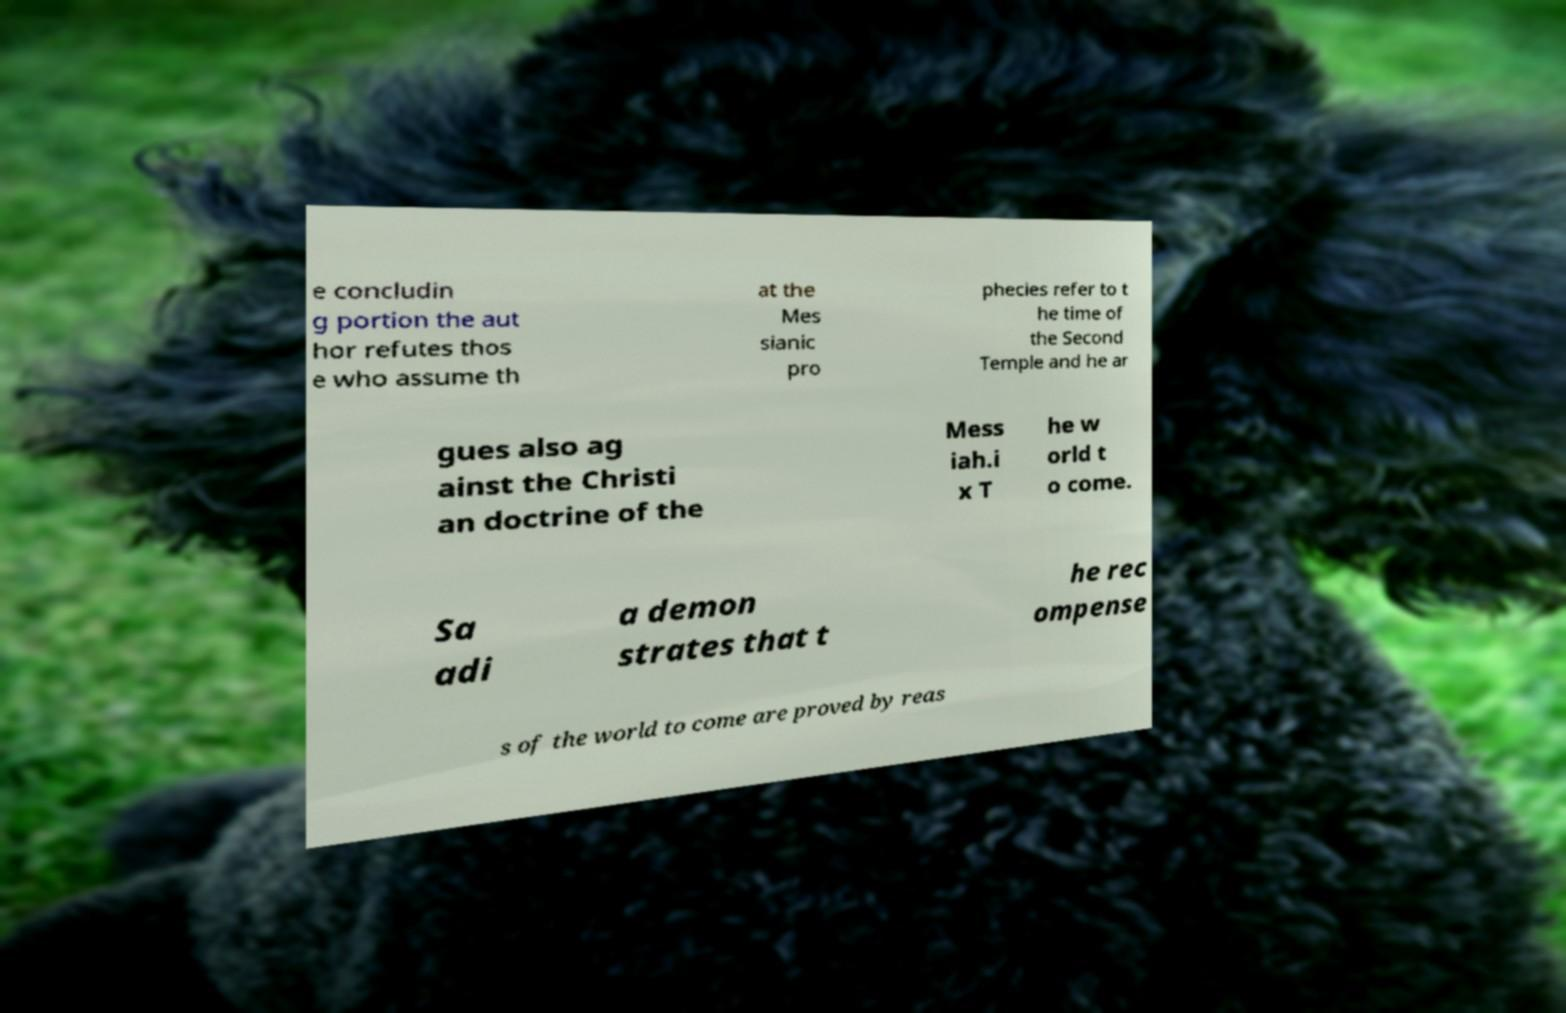Can you read and provide the text displayed in the image?This photo seems to have some interesting text. Can you extract and type it out for me? e concludin g portion the aut hor refutes thos e who assume th at the Mes sianic pro phecies refer to t he time of the Second Temple and he ar gues also ag ainst the Christi an doctrine of the Mess iah.i x T he w orld t o come. Sa adi a demon strates that t he rec ompense s of the world to come are proved by reas 